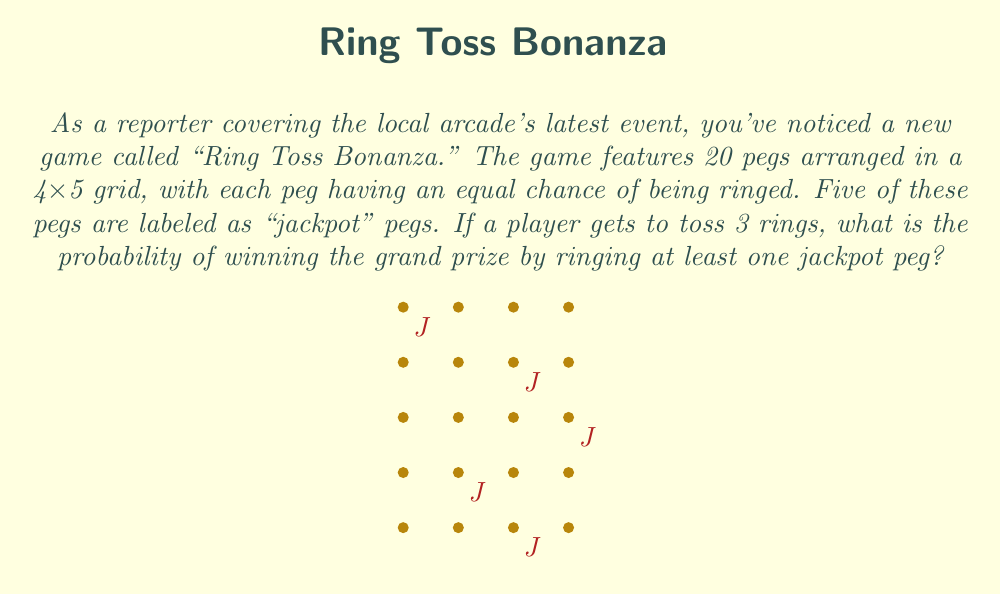What is the answer to this math problem? Let's approach this step-by-step:

1) First, let's calculate the probability of not hitting a jackpot peg with a single ring toss:
   $P(\text{no jackpot}) = \frac{15}{20} = \frac{3}{4}$

2) For the grand prize to be lost, all three tosses must miss the jackpot pegs. The probability of this happening is:
   $P(\text{all miss}) = (\frac{3}{4})^3 = \frac{27}{64}$

3) Therefore, the probability of winning (hitting at least one jackpot peg) is the complement of this probability:
   $P(\text{win}) = 1 - P(\text{all miss}) = 1 - \frac{27}{64} = \frac{64-27}{64} = \frac{37}{64}$

4) This can be simplified by dividing both numerator and denominator by their greatest common divisor (1):
   $\frac{37}{64}$ (already in its simplest form)

5) To convert to a percentage:
   $\frac{37}{64} \approx 0.578125 = 57.8125\%$
Answer: $\frac{37}{64}$ or approximately 57.8125% 